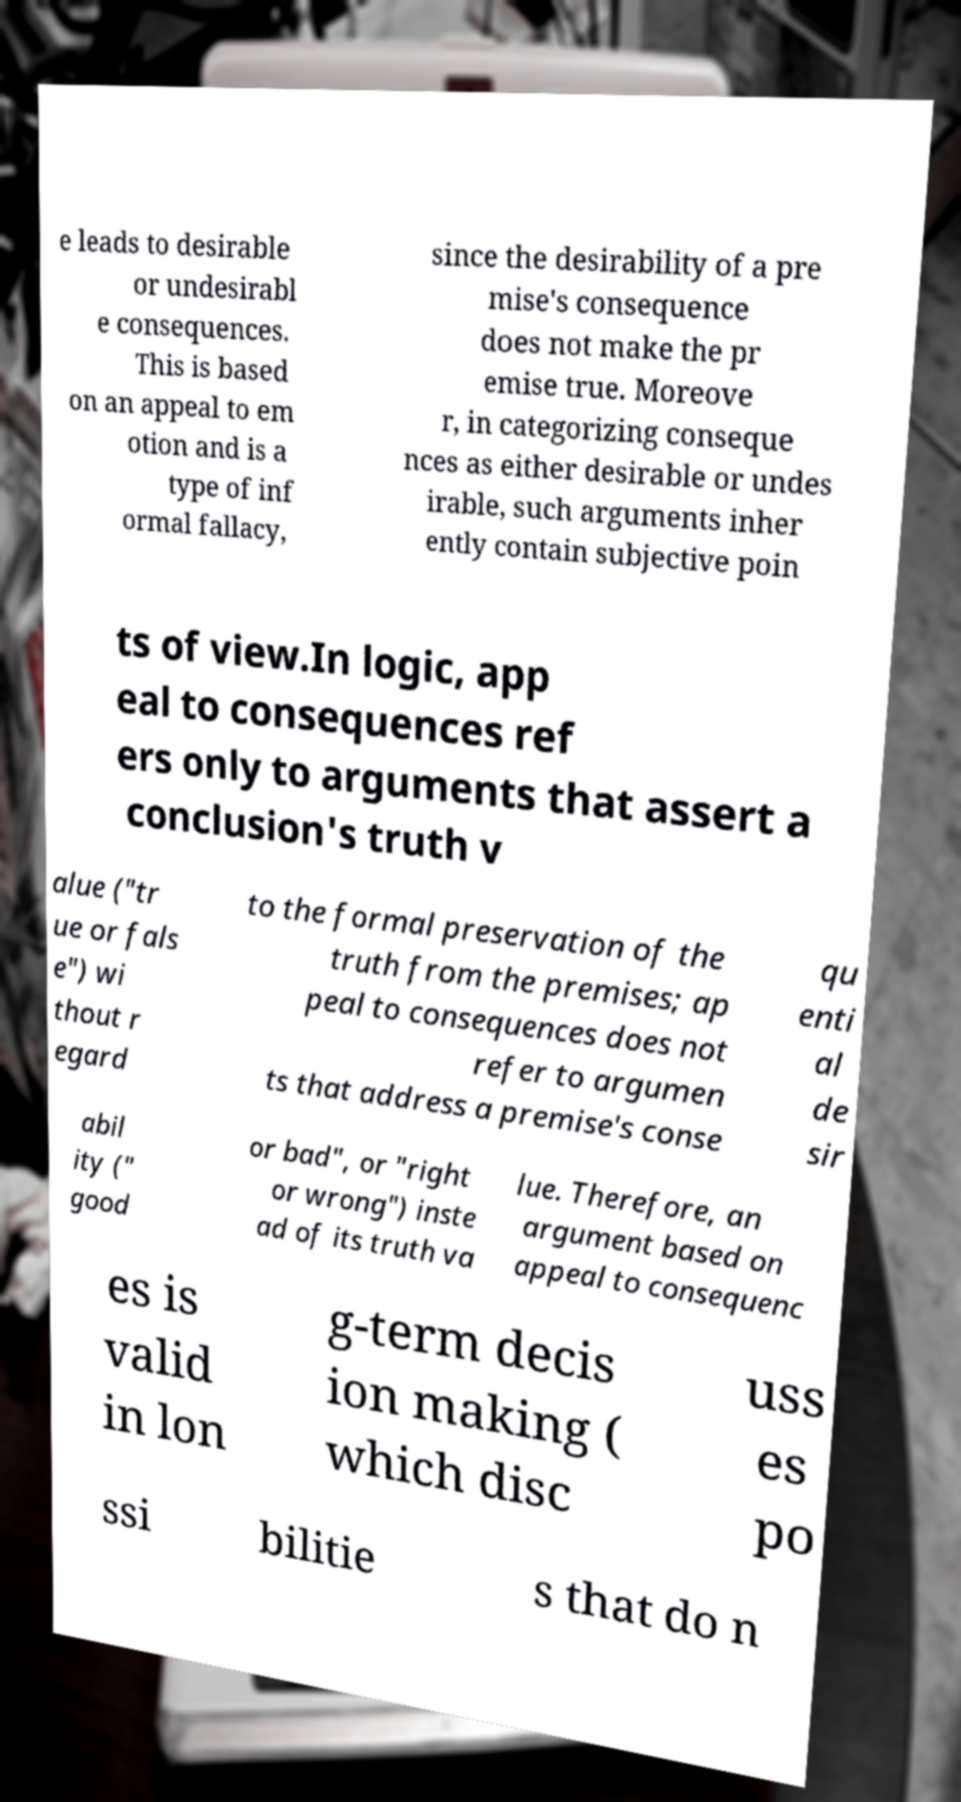For documentation purposes, I need the text within this image transcribed. Could you provide that? e leads to desirable or undesirabl e consequences. This is based on an appeal to em otion and is a type of inf ormal fallacy, since the desirability of a pre mise's consequence does not make the pr emise true. Moreove r, in categorizing conseque nces as either desirable or undes irable, such arguments inher ently contain subjective poin ts of view.In logic, app eal to consequences ref ers only to arguments that assert a conclusion's truth v alue ("tr ue or fals e") wi thout r egard to the formal preservation of the truth from the premises; ap peal to consequences does not refer to argumen ts that address a premise's conse qu enti al de sir abil ity (" good or bad", or "right or wrong") inste ad of its truth va lue. Therefore, an argument based on appeal to consequenc es is valid in lon g-term decis ion making ( which disc uss es po ssi bilitie s that do n 